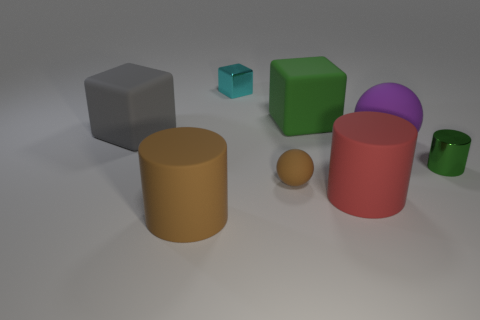Subtract all red cylinders. How many cylinders are left? 2 Subtract all red blocks. Subtract all red cylinders. How many blocks are left? 3 Subtract all spheres. How many objects are left? 6 Add 2 tiny gray things. How many objects exist? 10 Add 5 cyan metal things. How many cyan metal things exist? 6 Subtract 0 yellow cylinders. How many objects are left? 8 Subtract all shiny cubes. Subtract all tiny green metallic cylinders. How many objects are left? 6 Add 3 green rubber objects. How many green rubber objects are left? 4 